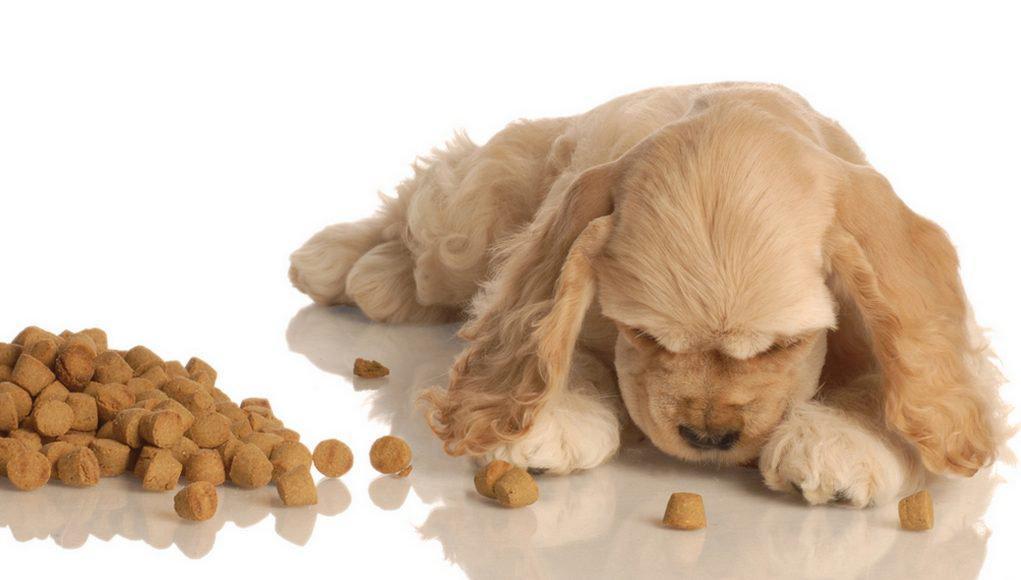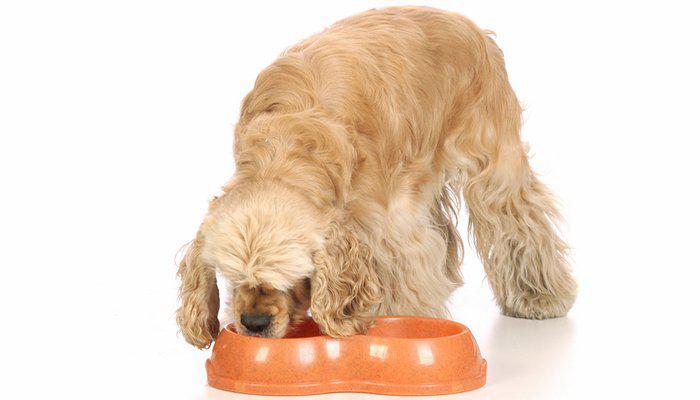The first image is the image on the left, the second image is the image on the right. For the images displayed, is the sentence "An image includes one golden cocker spaniel with its mouth on an orangish food bowl." factually correct? Answer yes or no. Yes. The first image is the image on the left, the second image is the image on the right. Examine the images to the left and right. Is the description "An image contains a dog food bowl." accurate? Answer yes or no. Yes. 